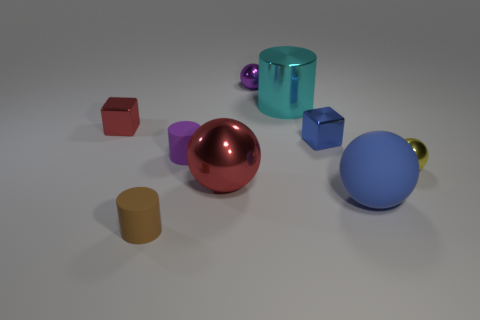How many other things are the same shape as the large cyan thing?
Keep it short and to the point. 2. There is a tiny red metallic object left of the tiny brown rubber cylinder; does it have the same shape as the blue thing that is on the left side of the blue rubber thing?
Ensure brevity in your answer.  Yes. How many tiny metal cubes are to the right of the tiny ball behind the small sphere in front of the small red metallic cube?
Your response must be concise. 1. What color is the big matte sphere?
Offer a very short reply. Blue. How many other things are the same size as the red metallic block?
Keep it short and to the point. 5. What is the material of the yellow object that is the same shape as the purple metal object?
Make the answer very short. Metal. What material is the blue object that is behind the matte thing that is to the right of the small sphere that is left of the cyan object?
Ensure brevity in your answer.  Metal. There is a blue object that is the same material as the small yellow ball; what is its size?
Your answer should be very brief. Small. Are there any other things of the same color as the large rubber thing?
Provide a short and direct response. Yes. There is a tiny cube left of the cyan cylinder; does it have the same color as the big sphere on the left side of the blue shiny object?
Make the answer very short. Yes. 